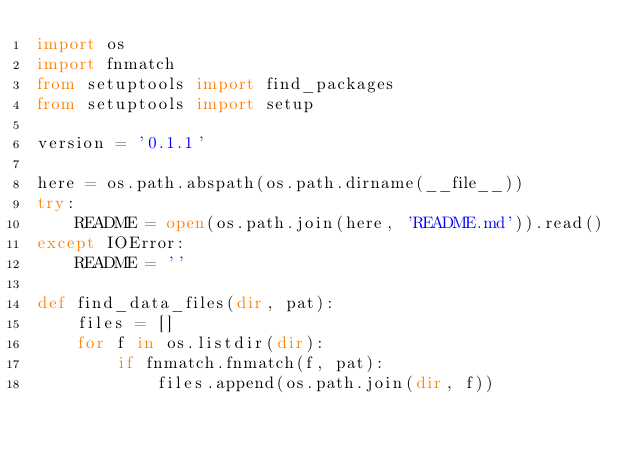Convert code to text. <code><loc_0><loc_0><loc_500><loc_500><_Python_>import os
import fnmatch
from setuptools import find_packages
from setuptools import setup

version = '0.1.1'

here = os.path.abspath(os.path.dirname(__file__))
try:
    README = open(os.path.join(here, 'README.md')).read()
except IOError:
    README = ''

def find_data_files(dir, pat):
    files = []
    for f in os.listdir(dir):
        if fnmatch.fnmatch(f, pat):
            files.append(os.path.join(dir, f))</code> 